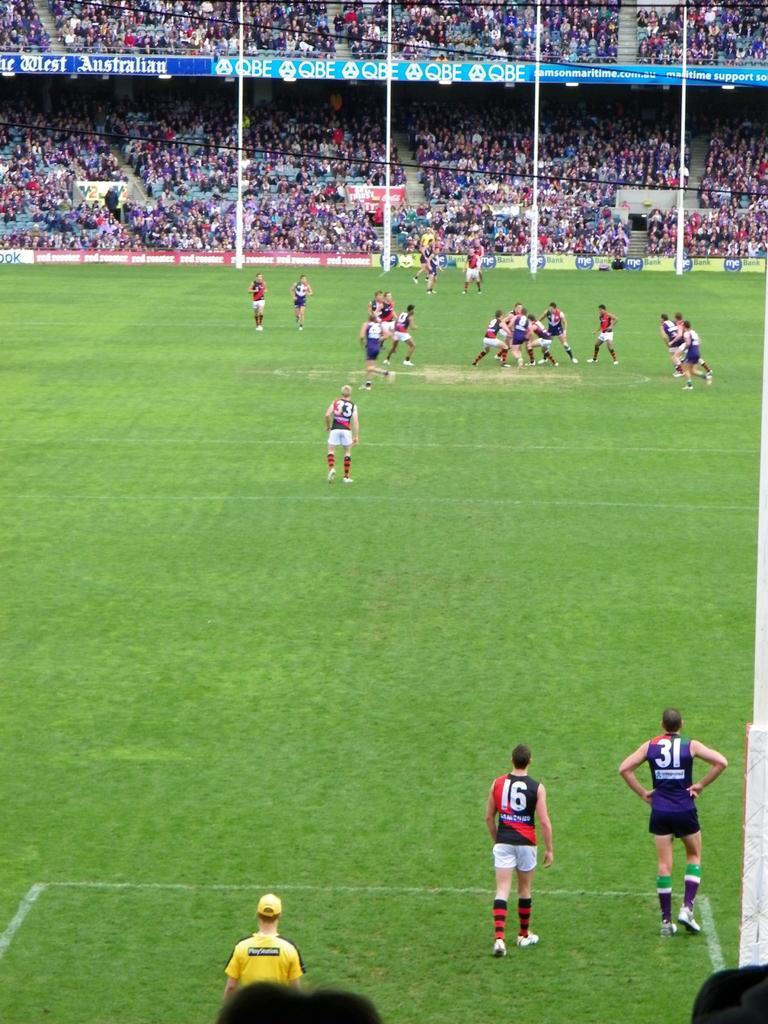Describe this image in one or two sentences. In this picture there are people and we can see grass. In the background of the image we can see poles, stadium, hoardings, wires and these are audience. 